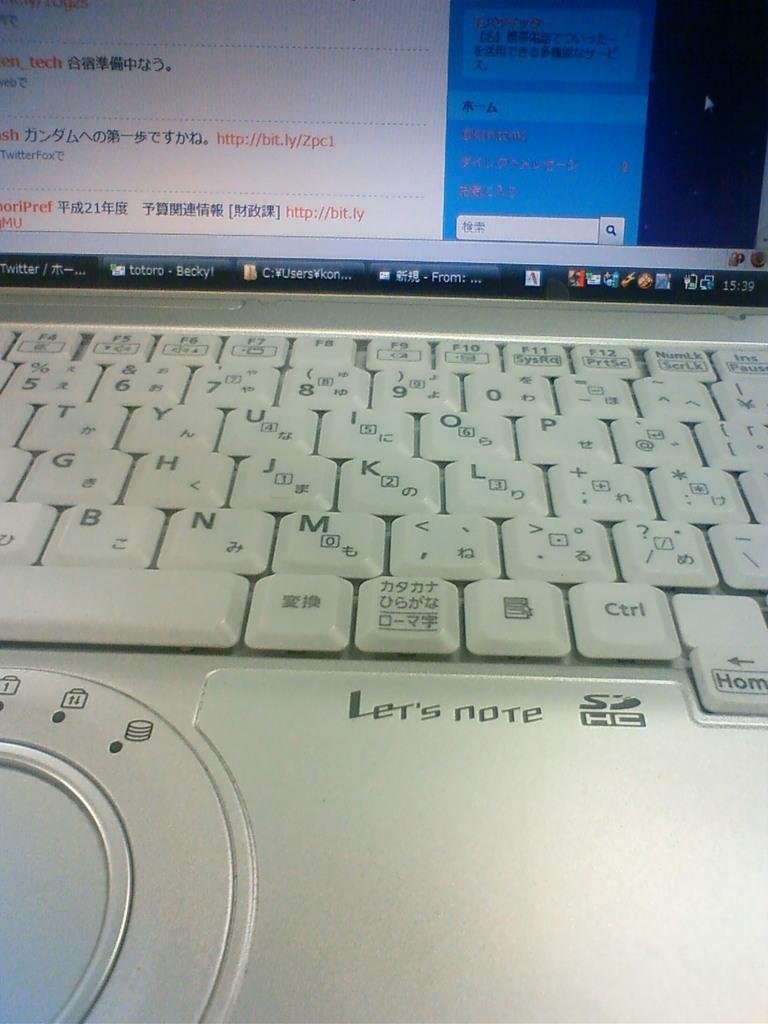Provide a one-sentence caption for the provided image. A silver computer which shows Chinese lettering and other applications. 